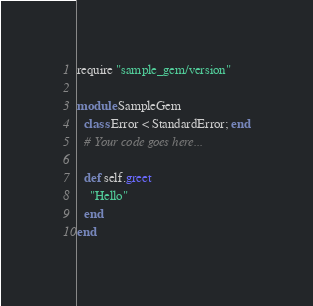Convert code to text. <code><loc_0><loc_0><loc_500><loc_500><_Ruby_>require "sample_gem/version"

module SampleGem
  class Error < StandardError; end
  # Your code goes here...

  def self.greet
    "Hello"
  end
end
</code> 